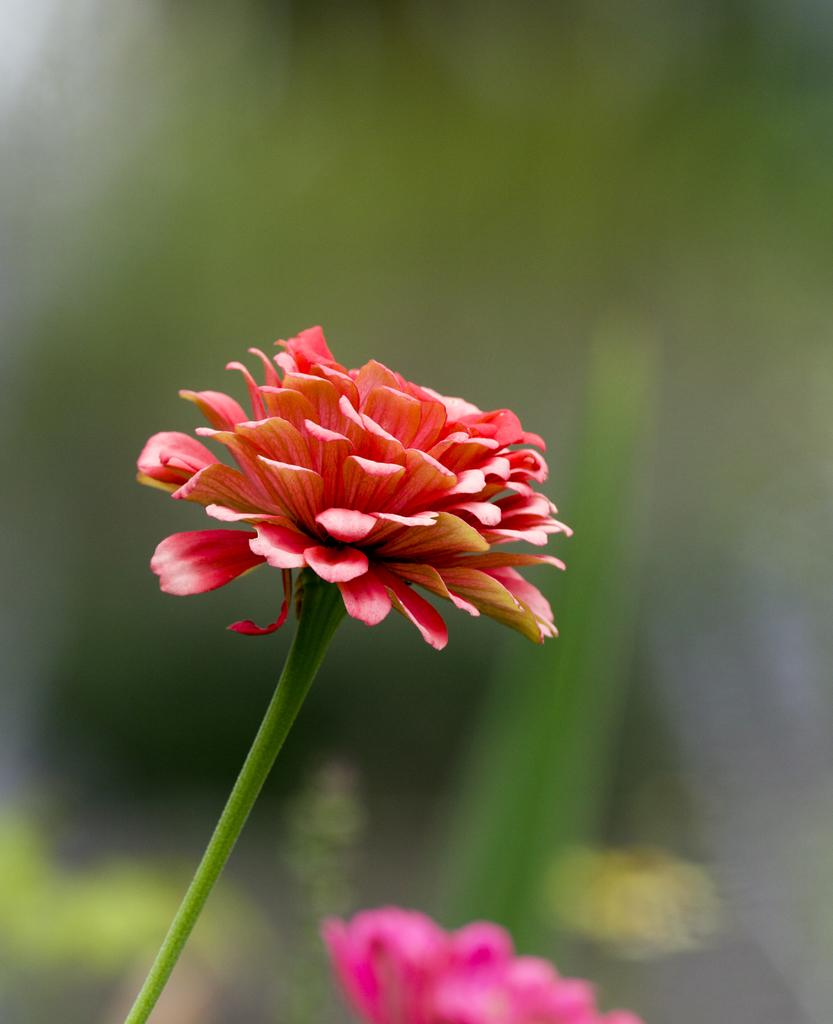What is the main subject of the picture? The main subject of the picture is a flower. Can you describe the background of the picture? The background of the picture is blurry. What are the main features of the flower? The flower has petals. How many people can be seen in the library in the image? There is no library or people present in the image; it features a flower with a blurry background. What type of birds can be seen flying around the flower in the image? There are no birds present in the image; it features a flower with a blurry background. 